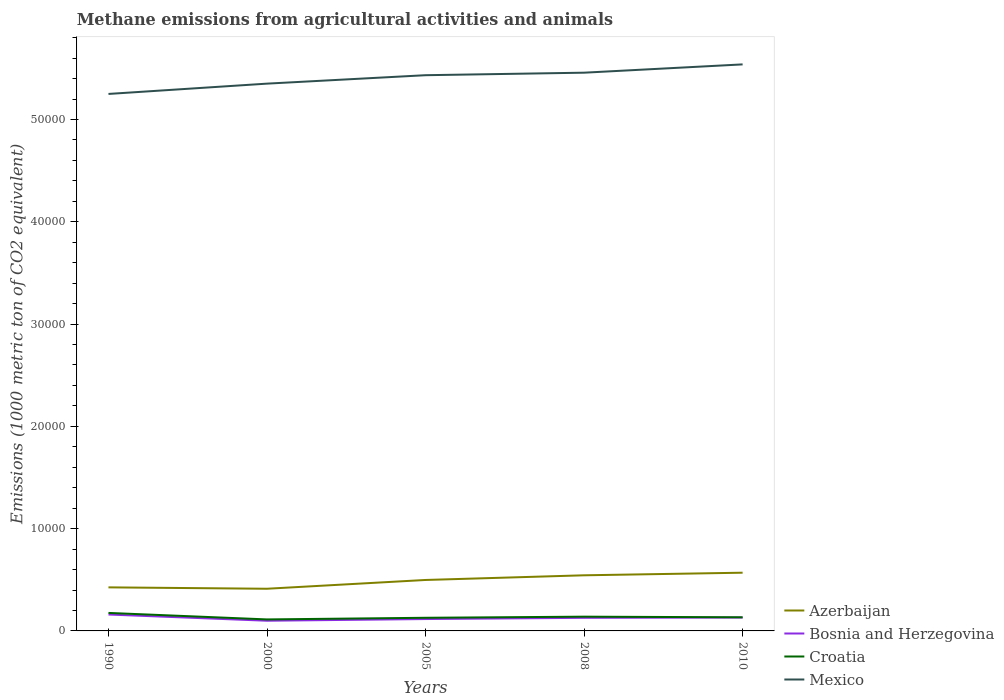Is the number of lines equal to the number of legend labels?
Offer a terse response. Yes. Across all years, what is the maximum amount of methane emitted in Azerbaijan?
Offer a terse response. 4123.5. In which year was the amount of methane emitted in Mexico maximum?
Give a very brief answer. 1990. What is the total amount of methane emitted in Mexico in the graph?
Make the answer very short. -810.5. What is the difference between the highest and the second highest amount of methane emitted in Bosnia and Herzegovina?
Your answer should be compact. 607.7. What is the difference between the highest and the lowest amount of methane emitted in Bosnia and Herzegovina?
Your answer should be very brief. 3. What is the difference between two consecutive major ticks on the Y-axis?
Offer a terse response. 10000. Are the values on the major ticks of Y-axis written in scientific E-notation?
Ensure brevity in your answer.  No. Does the graph contain grids?
Your answer should be very brief. No. Where does the legend appear in the graph?
Ensure brevity in your answer.  Bottom right. How are the legend labels stacked?
Offer a very short reply. Vertical. What is the title of the graph?
Offer a terse response. Methane emissions from agricultural activities and animals. Does "Croatia" appear as one of the legend labels in the graph?
Provide a succinct answer. Yes. What is the label or title of the Y-axis?
Offer a terse response. Emissions (1000 metric ton of CO2 equivalent). What is the Emissions (1000 metric ton of CO2 equivalent) in Azerbaijan in 1990?
Keep it short and to the point. 4258.7. What is the Emissions (1000 metric ton of CO2 equivalent) in Bosnia and Herzegovina in 1990?
Offer a terse response. 1604.3. What is the Emissions (1000 metric ton of CO2 equivalent) in Croatia in 1990?
Keep it short and to the point. 1759.1. What is the Emissions (1000 metric ton of CO2 equivalent) in Mexico in 1990?
Your response must be concise. 5.25e+04. What is the Emissions (1000 metric ton of CO2 equivalent) in Azerbaijan in 2000?
Give a very brief answer. 4123.5. What is the Emissions (1000 metric ton of CO2 equivalent) of Bosnia and Herzegovina in 2000?
Your answer should be compact. 996.6. What is the Emissions (1000 metric ton of CO2 equivalent) of Croatia in 2000?
Offer a terse response. 1124.5. What is the Emissions (1000 metric ton of CO2 equivalent) of Mexico in 2000?
Make the answer very short. 5.35e+04. What is the Emissions (1000 metric ton of CO2 equivalent) in Azerbaijan in 2005?
Provide a short and direct response. 4981. What is the Emissions (1000 metric ton of CO2 equivalent) of Bosnia and Herzegovina in 2005?
Provide a short and direct response. 1161.2. What is the Emissions (1000 metric ton of CO2 equivalent) in Croatia in 2005?
Make the answer very short. 1285.2. What is the Emissions (1000 metric ton of CO2 equivalent) of Mexico in 2005?
Offer a terse response. 5.43e+04. What is the Emissions (1000 metric ton of CO2 equivalent) of Azerbaijan in 2008?
Give a very brief answer. 5438.1. What is the Emissions (1000 metric ton of CO2 equivalent) of Bosnia and Herzegovina in 2008?
Keep it short and to the point. 1279.4. What is the Emissions (1000 metric ton of CO2 equivalent) of Croatia in 2008?
Your answer should be compact. 1392.8. What is the Emissions (1000 metric ton of CO2 equivalent) in Mexico in 2008?
Ensure brevity in your answer.  5.46e+04. What is the Emissions (1000 metric ton of CO2 equivalent) in Azerbaijan in 2010?
Give a very brief answer. 5691.1. What is the Emissions (1000 metric ton of CO2 equivalent) of Bosnia and Herzegovina in 2010?
Your answer should be very brief. 1307.1. What is the Emissions (1000 metric ton of CO2 equivalent) of Croatia in 2010?
Your answer should be very brief. 1331.3. What is the Emissions (1000 metric ton of CO2 equivalent) of Mexico in 2010?
Offer a very short reply. 5.54e+04. Across all years, what is the maximum Emissions (1000 metric ton of CO2 equivalent) of Azerbaijan?
Keep it short and to the point. 5691.1. Across all years, what is the maximum Emissions (1000 metric ton of CO2 equivalent) of Bosnia and Herzegovina?
Your response must be concise. 1604.3. Across all years, what is the maximum Emissions (1000 metric ton of CO2 equivalent) in Croatia?
Offer a terse response. 1759.1. Across all years, what is the maximum Emissions (1000 metric ton of CO2 equivalent) of Mexico?
Your response must be concise. 5.54e+04. Across all years, what is the minimum Emissions (1000 metric ton of CO2 equivalent) in Azerbaijan?
Provide a succinct answer. 4123.5. Across all years, what is the minimum Emissions (1000 metric ton of CO2 equivalent) in Bosnia and Herzegovina?
Your answer should be compact. 996.6. Across all years, what is the minimum Emissions (1000 metric ton of CO2 equivalent) in Croatia?
Make the answer very short. 1124.5. Across all years, what is the minimum Emissions (1000 metric ton of CO2 equivalent) of Mexico?
Offer a very short reply. 5.25e+04. What is the total Emissions (1000 metric ton of CO2 equivalent) of Azerbaijan in the graph?
Provide a succinct answer. 2.45e+04. What is the total Emissions (1000 metric ton of CO2 equivalent) in Bosnia and Herzegovina in the graph?
Your answer should be very brief. 6348.6. What is the total Emissions (1000 metric ton of CO2 equivalent) in Croatia in the graph?
Keep it short and to the point. 6892.9. What is the total Emissions (1000 metric ton of CO2 equivalent) in Mexico in the graph?
Provide a succinct answer. 2.70e+05. What is the difference between the Emissions (1000 metric ton of CO2 equivalent) of Azerbaijan in 1990 and that in 2000?
Your response must be concise. 135.2. What is the difference between the Emissions (1000 metric ton of CO2 equivalent) in Bosnia and Herzegovina in 1990 and that in 2000?
Your answer should be compact. 607.7. What is the difference between the Emissions (1000 metric ton of CO2 equivalent) of Croatia in 1990 and that in 2000?
Give a very brief answer. 634.6. What is the difference between the Emissions (1000 metric ton of CO2 equivalent) of Mexico in 1990 and that in 2000?
Provide a succinct answer. -1007.1. What is the difference between the Emissions (1000 metric ton of CO2 equivalent) of Azerbaijan in 1990 and that in 2005?
Provide a succinct answer. -722.3. What is the difference between the Emissions (1000 metric ton of CO2 equivalent) in Bosnia and Herzegovina in 1990 and that in 2005?
Your answer should be very brief. 443.1. What is the difference between the Emissions (1000 metric ton of CO2 equivalent) of Croatia in 1990 and that in 2005?
Keep it short and to the point. 473.9. What is the difference between the Emissions (1000 metric ton of CO2 equivalent) in Mexico in 1990 and that in 2005?
Keep it short and to the point. -1831.1. What is the difference between the Emissions (1000 metric ton of CO2 equivalent) of Azerbaijan in 1990 and that in 2008?
Your answer should be very brief. -1179.4. What is the difference between the Emissions (1000 metric ton of CO2 equivalent) of Bosnia and Herzegovina in 1990 and that in 2008?
Keep it short and to the point. 324.9. What is the difference between the Emissions (1000 metric ton of CO2 equivalent) of Croatia in 1990 and that in 2008?
Offer a very short reply. 366.3. What is the difference between the Emissions (1000 metric ton of CO2 equivalent) in Mexico in 1990 and that in 2008?
Provide a short and direct response. -2077.8. What is the difference between the Emissions (1000 metric ton of CO2 equivalent) of Azerbaijan in 1990 and that in 2010?
Provide a short and direct response. -1432.4. What is the difference between the Emissions (1000 metric ton of CO2 equivalent) of Bosnia and Herzegovina in 1990 and that in 2010?
Provide a succinct answer. 297.2. What is the difference between the Emissions (1000 metric ton of CO2 equivalent) of Croatia in 1990 and that in 2010?
Provide a short and direct response. 427.8. What is the difference between the Emissions (1000 metric ton of CO2 equivalent) in Mexico in 1990 and that in 2010?
Keep it short and to the point. -2888.3. What is the difference between the Emissions (1000 metric ton of CO2 equivalent) in Azerbaijan in 2000 and that in 2005?
Your answer should be compact. -857.5. What is the difference between the Emissions (1000 metric ton of CO2 equivalent) of Bosnia and Herzegovina in 2000 and that in 2005?
Offer a terse response. -164.6. What is the difference between the Emissions (1000 metric ton of CO2 equivalent) of Croatia in 2000 and that in 2005?
Provide a succinct answer. -160.7. What is the difference between the Emissions (1000 metric ton of CO2 equivalent) in Mexico in 2000 and that in 2005?
Offer a terse response. -824. What is the difference between the Emissions (1000 metric ton of CO2 equivalent) in Azerbaijan in 2000 and that in 2008?
Offer a very short reply. -1314.6. What is the difference between the Emissions (1000 metric ton of CO2 equivalent) in Bosnia and Herzegovina in 2000 and that in 2008?
Make the answer very short. -282.8. What is the difference between the Emissions (1000 metric ton of CO2 equivalent) of Croatia in 2000 and that in 2008?
Your response must be concise. -268.3. What is the difference between the Emissions (1000 metric ton of CO2 equivalent) of Mexico in 2000 and that in 2008?
Provide a succinct answer. -1070.7. What is the difference between the Emissions (1000 metric ton of CO2 equivalent) of Azerbaijan in 2000 and that in 2010?
Give a very brief answer. -1567.6. What is the difference between the Emissions (1000 metric ton of CO2 equivalent) in Bosnia and Herzegovina in 2000 and that in 2010?
Keep it short and to the point. -310.5. What is the difference between the Emissions (1000 metric ton of CO2 equivalent) of Croatia in 2000 and that in 2010?
Make the answer very short. -206.8. What is the difference between the Emissions (1000 metric ton of CO2 equivalent) in Mexico in 2000 and that in 2010?
Give a very brief answer. -1881.2. What is the difference between the Emissions (1000 metric ton of CO2 equivalent) of Azerbaijan in 2005 and that in 2008?
Give a very brief answer. -457.1. What is the difference between the Emissions (1000 metric ton of CO2 equivalent) in Bosnia and Herzegovina in 2005 and that in 2008?
Your response must be concise. -118.2. What is the difference between the Emissions (1000 metric ton of CO2 equivalent) of Croatia in 2005 and that in 2008?
Provide a succinct answer. -107.6. What is the difference between the Emissions (1000 metric ton of CO2 equivalent) of Mexico in 2005 and that in 2008?
Your answer should be compact. -246.7. What is the difference between the Emissions (1000 metric ton of CO2 equivalent) of Azerbaijan in 2005 and that in 2010?
Provide a short and direct response. -710.1. What is the difference between the Emissions (1000 metric ton of CO2 equivalent) of Bosnia and Herzegovina in 2005 and that in 2010?
Your response must be concise. -145.9. What is the difference between the Emissions (1000 metric ton of CO2 equivalent) of Croatia in 2005 and that in 2010?
Keep it short and to the point. -46.1. What is the difference between the Emissions (1000 metric ton of CO2 equivalent) of Mexico in 2005 and that in 2010?
Give a very brief answer. -1057.2. What is the difference between the Emissions (1000 metric ton of CO2 equivalent) of Azerbaijan in 2008 and that in 2010?
Make the answer very short. -253. What is the difference between the Emissions (1000 metric ton of CO2 equivalent) in Bosnia and Herzegovina in 2008 and that in 2010?
Provide a short and direct response. -27.7. What is the difference between the Emissions (1000 metric ton of CO2 equivalent) in Croatia in 2008 and that in 2010?
Give a very brief answer. 61.5. What is the difference between the Emissions (1000 metric ton of CO2 equivalent) of Mexico in 2008 and that in 2010?
Your response must be concise. -810.5. What is the difference between the Emissions (1000 metric ton of CO2 equivalent) in Azerbaijan in 1990 and the Emissions (1000 metric ton of CO2 equivalent) in Bosnia and Herzegovina in 2000?
Ensure brevity in your answer.  3262.1. What is the difference between the Emissions (1000 metric ton of CO2 equivalent) in Azerbaijan in 1990 and the Emissions (1000 metric ton of CO2 equivalent) in Croatia in 2000?
Provide a short and direct response. 3134.2. What is the difference between the Emissions (1000 metric ton of CO2 equivalent) in Azerbaijan in 1990 and the Emissions (1000 metric ton of CO2 equivalent) in Mexico in 2000?
Offer a terse response. -4.92e+04. What is the difference between the Emissions (1000 metric ton of CO2 equivalent) of Bosnia and Herzegovina in 1990 and the Emissions (1000 metric ton of CO2 equivalent) of Croatia in 2000?
Your response must be concise. 479.8. What is the difference between the Emissions (1000 metric ton of CO2 equivalent) of Bosnia and Herzegovina in 1990 and the Emissions (1000 metric ton of CO2 equivalent) of Mexico in 2000?
Keep it short and to the point. -5.19e+04. What is the difference between the Emissions (1000 metric ton of CO2 equivalent) of Croatia in 1990 and the Emissions (1000 metric ton of CO2 equivalent) of Mexico in 2000?
Provide a succinct answer. -5.17e+04. What is the difference between the Emissions (1000 metric ton of CO2 equivalent) of Azerbaijan in 1990 and the Emissions (1000 metric ton of CO2 equivalent) of Bosnia and Herzegovina in 2005?
Ensure brevity in your answer.  3097.5. What is the difference between the Emissions (1000 metric ton of CO2 equivalent) in Azerbaijan in 1990 and the Emissions (1000 metric ton of CO2 equivalent) in Croatia in 2005?
Keep it short and to the point. 2973.5. What is the difference between the Emissions (1000 metric ton of CO2 equivalent) in Azerbaijan in 1990 and the Emissions (1000 metric ton of CO2 equivalent) in Mexico in 2005?
Provide a short and direct response. -5.01e+04. What is the difference between the Emissions (1000 metric ton of CO2 equivalent) of Bosnia and Herzegovina in 1990 and the Emissions (1000 metric ton of CO2 equivalent) of Croatia in 2005?
Give a very brief answer. 319.1. What is the difference between the Emissions (1000 metric ton of CO2 equivalent) of Bosnia and Herzegovina in 1990 and the Emissions (1000 metric ton of CO2 equivalent) of Mexico in 2005?
Your response must be concise. -5.27e+04. What is the difference between the Emissions (1000 metric ton of CO2 equivalent) in Croatia in 1990 and the Emissions (1000 metric ton of CO2 equivalent) in Mexico in 2005?
Offer a very short reply. -5.26e+04. What is the difference between the Emissions (1000 metric ton of CO2 equivalent) in Azerbaijan in 1990 and the Emissions (1000 metric ton of CO2 equivalent) in Bosnia and Herzegovina in 2008?
Offer a terse response. 2979.3. What is the difference between the Emissions (1000 metric ton of CO2 equivalent) of Azerbaijan in 1990 and the Emissions (1000 metric ton of CO2 equivalent) of Croatia in 2008?
Your response must be concise. 2865.9. What is the difference between the Emissions (1000 metric ton of CO2 equivalent) in Azerbaijan in 1990 and the Emissions (1000 metric ton of CO2 equivalent) in Mexico in 2008?
Your answer should be very brief. -5.03e+04. What is the difference between the Emissions (1000 metric ton of CO2 equivalent) of Bosnia and Herzegovina in 1990 and the Emissions (1000 metric ton of CO2 equivalent) of Croatia in 2008?
Keep it short and to the point. 211.5. What is the difference between the Emissions (1000 metric ton of CO2 equivalent) of Bosnia and Herzegovina in 1990 and the Emissions (1000 metric ton of CO2 equivalent) of Mexico in 2008?
Offer a terse response. -5.30e+04. What is the difference between the Emissions (1000 metric ton of CO2 equivalent) of Croatia in 1990 and the Emissions (1000 metric ton of CO2 equivalent) of Mexico in 2008?
Your answer should be compact. -5.28e+04. What is the difference between the Emissions (1000 metric ton of CO2 equivalent) in Azerbaijan in 1990 and the Emissions (1000 metric ton of CO2 equivalent) in Bosnia and Herzegovina in 2010?
Your answer should be compact. 2951.6. What is the difference between the Emissions (1000 metric ton of CO2 equivalent) in Azerbaijan in 1990 and the Emissions (1000 metric ton of CO2 equivalent) in Croatia in 2010?
Make the answer very short. 2927.4. What is the difference between the Emissions (1000 metric ton of CO2 equivalent) in Azerbaijan in 1990 and the Emissions (1000 metric ton of CO2 equivalent) in Mexico in 2010?
Your answer should be compact. -5.11e+04. What is the difference between the Emissions (1000 metric ton of CO2 equivalent) of Bosnia and Herzegovina in 1990 and the Emissions (1000 metric ton of CO2 equivalent) of Croatia in 2010?
Your response must be concise. 273. What is the difference between the Emissions (1000 metric ton of CO2 equivalent) of Bosnia and Herzegovina in 1990 and the Emissions (1000 metric ton of CO2 equivalent) of Mexico in 2010?
Offer a very short reply. -5.38e+04. What is the difference between the Emissions (1000 metric ton of CO2 equivalent) in Croatia in 1990 and the Emissions (1000 metric ton of CO2 equivalent) in Mexico in 2010?
Provide a succinct answer. -5.36e+04. What is the difference between the Emissions (1000 metric ton of CO2 equivalent) of Azerbaijan in 2000 and the Emissions (1000 metric ton of CO2 equivalent) of Bosnia and Herzegovina in 2005?
Keep it short and to the point. 2962.3. What is the difference between the Emissions (1000 metric ton of CO2 equivalent) of Azerbaijan in 2000 and the Emissions (1000 metric ton of CO2 equivalent) of Croatia in 2005?
Make the answer very short. 2838.3. What is the difference between the Emissions (1000 metric ton of CO2 equivalent) of Azerbaijan in 2000 and the Emissions (1000 metric ton of CO2 equivalent) of Mexico in 2005?
Offer a very short reply. -5.02e+04. What is the difference between the Emissions (1000 metric ton of CO2 equivalent) of Bosnia and Herzegovina in 2000 and the Emissions (1000 metric ton of CO2 equivalent) of Croatia in 2005?
Provide a short and direct response. -288.6. What is the difference between the Emissions (1000 metric ton of CO2 equivalent) in Bosnia and Herzegovina in 2000 and the Emissions (1000 metric ton of CO2 equivalent) in Mexico in 2005?
Provide a short and direct response. -5.33e+04. What is the difference between the Emissions (1000 metric ton of CO2 equivalent) of Croatia in 2000 and the Emissions (1000 metric ton of CO2 equivalent) of Mexico in 2005?
Ensure brevity in your answer.  -5.32e+04. What is the difference between the Emissions (1000 metric ton of CO2 equivalent) in Azerbaijan in 2000 and the Emissions (1000 metric ton of CO2 equivalent) in Bosnia and Herzegovina in 2008?
Make the answer very short. 2844.1. What is the difference between the Emissions (1000 metric ton of CO2 equivalent) in Azerbaijan in 2000 and the Emissions (1000 metric ton of CO2 equivalent) in Croatia in 2008?
Provide a short and direct response. 2730.7. What is the difference between the Emissions (1000 metric ton of CO2 equivalent) of Azerbaijan in 2000 and the Emissions (1000 metric ton of CO2 equivalent) of Mexico in 2008?
Give a very brief answer. -5.05e+04. What is the difference between the Emissions (1000 metric ton of CO2 equivalent) in Bosnia and Herzegovina in 2000 and the Emissions (1000 metric ton of CO2 equivalent) in Croatia in 2008?
Provide a short and direct response. -396.2. What is the difference between the Emissions (1000 metric ton of CO2 equivalent) of Bosnia and Herzegovina in 2000 and the Emissions (1000 metric ton of CO2 equivalent) of Mexico in 2008?
Your answer should be compact. -5.36e+04. What is the difference between the Emissions (1000 metric ton of CO2 equivalent) in Croatia in 2000 and the Emissions (1000 metric ton of CO2 equivalent) in Mexico in 2008?
Provide a succinct answer. -5.35e+04. What is the difference between the Emissions (1000 metric ton of CO2 equivalent) in Azerbaijan in 2000 and the Emissions (1000 metric ton of CO2 equivalent) in Bosnia and Herzegovina in 2010?
Keep it short and to the point. 2816.4. What is the difference between the Emissions (1000 metric ton of CO2 equivalent) in Azerbaijan in 2000 and the Emissions (1000 metric ton of CO2 equivalent) in Croatia in 2010?
Provide a succinct answer. 2792.2. What is the difference between the Emissions (1000 metric ton of CO2 equivalent) of Azerbaijan in 2000 and the Emissions (1000 metric ton of CO2 equivalent) of Mexico in 2010?
Provide a short and direct response. -5.13e+04. What is the difference between the Emissions (1000 metric ton of CO2 equivalent) in Bosnia and Herzegovina in 2000 and the Emissions (1000 metric ton of CO2 equivalent) in Croatia in 2010?
Your answer should be compact. -334.7. What is the difference between the Emissions (1000 metric ton of CO2 equivalent) in Bosnia and Herzegovina in 2000 and the Emissions (1000 metric ton of CO2 equivalent) in Mexico in 2010?
Offer a very short reply. -5.44e+04. What is the difference between the Emissions (1000 metric ton of CO2 equivalent) of Croatia in 2000 and the Emissions (1000 metric ton of CO2 equivalent) of Mexico in 2010?
Keep it short and to the point. -5.43e+04. What is the difference between the Emissions (1000 metric ton of CO2 equivalent) in Azerbaijan in 2005 and the Emissions (1000 metric ton of CO2 equivalent) in Bosnia and Herzegovina in 2008?
Provide a succinct answer. 3701.6. What is the difference between the Emissions (1000 metric ton of CO2 equivalent) in Azerbaijan in 2005 and the Emissions (1000 metric ton of CO2 equivalent) in Croatia in 2008?
Keep it short and to the point. 3588.2. What is the difference between the Emissions (1000 metric ton of CO2 equivalent) of Azerbaijan in 2005 and the Emissions (1000 metric ton of CO2 equivalent) of Mexico in 2008?
Keep it short and to the point. -4.96e+04. What is the difference between the Emissions (1000 metric ton of CO2 equivalent) of Bosnia and Herzegovina in 2005 and the Emissions (1000 metric ton of CO2 equivalent) of Croatia in 2008?
Ensure brevity in your answer.  -231.6. What is the difference between the Emissions (1000 metric ton of CO2 equivalent) in Bosnia and Herzegovina in 2005 and the Emissions (1000 metric ton of CO2 equivalent) in Mexico in 2008?
Offer a very short reply. -5.34e+04. What is the difference between the Emissions (1000 metric ton of CO2 equivalent) in Croatia in 2005 and the Emissions (1000 metric ton of CO2 equivalent) in Mexico in 2008?
Provide a short and direct response. -5.33e+04. What is the difference between the Emissions (1000 metric ton of CO2 equivalent) of Azerbaijan in 2005 and the Emissions (1000 metric ton of CO2 equivalent) of Bosnia and Herzegovina in 2010?
Your response must be concise. 3673.9. What is the difference between the Emissions (1000 metric ton of CO2 equivalent) of Azerbaijan in 2005 and the Emissions (1000 metric ton of CO2 equivalent) of Croatia in 2010?
Your response must be concise. 3649.7. What is the difference between the Emissions (1000 metric ton of CO2 equivalent) of Azerbaijan in 2005 and the Emissions (1000 metric ton of CO2 equivalent) of Mexico in 2010?
Provide a succinct answer. -5.04e+04. What is the difference between the Emissions (1000 metric ton of CO2 equivalent) of Bosnia and Herzegovina in 2005 and the Emissions (1000 metric ton of CO2 equivalent) of Croatia in 2010?
Offer a terse response. -170.1. What is the difference between the Emissions (1000 metric ton of CO2 equivalent) of Bosnia and Herzegovina in 2005 and the Emissions (1000 metric ton of CO2 equivalent) of Mexico in 2010?
Your answer should be compact. -5.42e+04. What is the difference between the Emissions (1000 metric ton of CO2 equivalent) of Croatia in 2005 and the Emissions (1000 metric ton of CO2 equivalent) of Mexico in 2010?
Ensure brevity in your answer.  -5.41e+04. What is the difference between the Emissions (1000 metric ton of CO2 equivalent) of Azerbaijan in 2008 and the Emissions (1000 metric ton of CO2 equivalent) of Bosnia and Herzegovina in 2010?
Ensure brevity in your answer.  4131. What is the difference between the Emissions (1000 metric ton of CO2 equivalent) of Azerbaijan in 2008 and the Emissions (1000 metric ton of CO2 equivalent) of Croatia in 2010?
Provide a succinct answer. 4106.8. What is the difference between the Emissions (1000 metric ton of CO2 equivalent) of Azerbaijan in 2008 and the Emissions (1000 metric ton of CO2 equivalent) of Mexico in 2010?
Your answer should be very brief. -4.99e+04. What is the difference between the Emissions (1000 metric ton of CO2 equivalent) in Bosnia and Herzegovina in 2008 and the Emissions (1000 metric ton of CO2 equivalent) in Croatia in 2010?
Your answer should be compact. -51.9. What is the difference between the Emissions (1000 metric ton of CO2 equivalent) in Bosnia and Herzegovina in 2008 and the Emissions (1000 metric ton of CO2 equivalent) in Mexico in 2010?
Provide a succinct answer. -5.41e+04. What is the difference between the Emissions (1000 metric ton of CO2 equivalent) of Croatia in 2008 and the Emissions (1000 metric ton of CO2 equivalent) of Mexico in 2010?
Your answer should be compact. -5.40e+04. What is the average Emissions (1000 metric ton of CO2 equivalent) of Azerbaijan per year?
Offer a terse response. 4898.48. What is the average Emissions (1000 metric ton of CO2 equivalent) of Bosnia and Herzegovina per year?
Ensure brevity in your answer.  1269.72. What is the average Emissions (1000 metric ton of CO2 equivalent) of Croatia per year?
Ensure brevity in your answer.  1378.58. What is the average Emissions (1000 metric ton of CO2 equivalent) of Mexico per year?
Your answer should be compact. 5.41e+04. In the year 1990, what is the difference between the Emissions (1000 metric ton of CO2 equivalent) in Azerbaijan and Emissions (1000 metric ton of CO2 equivalent) in Bosnia and Herzegovina?
Your response must be concise. 2654.4. In the year 1990, what is the difference between the Emissions (1000 metric ton of CO2 equivalent) of Azerbaijan and Emissions (1000 metric ton of CO2 equivalent) of Croatia?
Your response must be concise. 2499.6. In the year 1990, what is the difference between the Emissions (1000 metric ton of CO2 equivalent) of Azerbaijan and Emissions (1000 metric ton of CO2 equivalent) of Mexico?
Your answer should be very brief. -4.82e+04. In the year 1990, what is the difference between the Emissions (1000 metric ton of CO2 equivalent) of Bosnia and Herzegovina and Emissions (1000 metric ton of CO2 equivalent) of Croatia?
Give a very brief answer. -154.8. In the year 1990, what is the difference between the Emissions (1000 metric ton of CO2 equivalent) in Bosnia and Herzegovina and Emissions (1000 metric ton of CO2 equivalent) in Mexico?
Offer a terse response. -5.09e+04. In the year 1990, what is the difference between the Emissions (1000 metric ton of CO2 equivalent) of Croatia and Emissions (1000 metric ton of CO2 equivalent) of Mexico?
Give a very brief answer. -5.07e+04. In the year 2000, what is the difference between the Emissions (1000 metric ton of CO2 equivalent) of Azerbaijan and Emissions (1000 metric ton of CO2 equivalent) of Bosnia and Herzegovina?
Your answer should be compact. 3126.9. In the year 2000, what is the difference between the Emissions (1000 metric ton of CO2 equivalent) in Azerbaijan and Emissions (1000 metric ton of CO2 equivalent) in Croatia?
Your answer should be compact. 2999. In the year 2000, what is the difference between the Emissions (1000 metric ton of CO2 equivalent) of Azerbaijan and Emissions (1000 metric ton of CO2 equivalent) of Mexico?
Your response must be concise. -4.94e+04. In the year 2000, what is the difference between the Emissions (1000 metric ton of CO2 equivalent) of Bosnia and Herzegovina and Emissions (1000 metric ton of CO2 equivalent) of Croatia?
Offer a terse response. -127.9. In the year 2000, what is the difference between the Emissions (1000 metric ton of CO2 equivalent) in Bosnia and Herzegovina and Emissions (1000 metric ton of CO2 equivalent) in Mexico?
Give a very brief answer. -5.25e+04. In the year 2000, what is the difference between the Emissions (1000 metric ton of CO2 equivalent) of Croatia and Emissions (1000 metric ton of CO2 equivalent) of Mexico?
Offer a very short reply. -5.24e+04. In the year 2005, what is the difference between the Emissions (1000 metric ton of CO2 equivalent) of Azerbaijan and Emissions (1000 metric ton of CO2 equivalent) of Bosnia and Herzegovina?
Offer a very short reply. 3819.8. In the year 2005, what is the difference between the Emissions (1000 metric ton of CO2 equivalent) of Azerbaijan and Emissions (1000 metric ton of CO2 equivalent) of Croatia?
Provide a succinct answer. 3695.8. In the year 2005, what is the difference between the Emissions (1000 metric ton of CO2 equivalent) of Azerbaijan and Emissions (1000 metric ton of CO2 equivalent) of Mexico?
Ensure brevity in your answer.  -4.93e+04. In the year 2005, what is the difference between the Emissions (1000 metric ton of CO2 equivalent) of Bosnia and Herzegovina and Emissions (1000 metric ton of CO2 equivalent) of Croatia?
Keep it short and to the point. -124. In the year 2005, what is the difference between the Emissions (1000 metric ton of CO2 equivalent) of Bosnia and Herzegovina and Emissions (1000 metric ton of CO2 equivalent) of Mexico?
Provide a short and direct response. -5.32e+04. In the year 2005, what is the difference between the Emissions (1000 metric ton of CO2 equivalent) in Croatia and Emissions (1000 metric ton of CO2 equivalent) in Mexico?
Your answer should be very brief. -5.30e+04. In the year 2008, what is the difference between the Emissions (1000 metric ton of CO2 equivalent) in Azerbaijan and Emissions (1000 metric ton of CO2 equivalent) in Bosnia and Herzegovina?
Your answer should be very brief. 4158.7. In the year 2008, what is the difference between the Emissions (1000 metric ton of CO2 equivalent) in Azerbaijan and Emissions (1000 metric ton of CO2 equivalent) in Croatia?
Ensure brevity in your answer.  4045.3. In the year 2008, what is the difference between the Emissions (1000 metric ton of CO2 equivalent) in Azerbaijan and Emissions (1000 metric ton of CO2 equivalent) in Mexico?
Make the answer very short. -4.91e+04. In the year 2008, what is the difference between the Emissions (1000 metric ton of CO2 equivalent) of Bosnia and Herzegovina and Emissions (1000 metric ton of CO2 equivalent) of Croatia?
Your response must be concise. -113.4. In the year 2008, what is the difference between the Emissions (1000 metric ton of CO2 equivalent) of Bosnia and Herzegovina and Emissions (1000 metric ton of CO2 equivalent) of Mexico?
Make the answer very short. -5.33e+04. In the year 2008, what is the difference between the Emissions (1000 metric ton of CO2 equivalent) of Croatia and Emissions (1000 metric ton of CO2 equivalent) of Mexico?
Your answer should be very brief. -5.32e+04. In the year 2010, what is the difference between the Emissions (1000 metric ton of CO2 equivalent) of Azerbaijan and Emissions (1000 metric ton of CO2 equivalent) of Bosnia and Herzegovina?
Your answer should be compact. 4384. In the year 2010, what is the difference between the Emissions (1000 metric ton of CO2 equivalent) in Azerbaijan and Emissions (1000 metric ton of CO2 equivalent) in Croatia?
Provide a short and direct response. 4359.8. In the year 2010, what is the difference between the Emissions (1000 metric ton of CO2 equivalent) in Azerbaijan and Emissions (1000 metric ton of CO2 equivalent) in Mexico?
Your answer should be very brief. -4.97e+04. In the year 2010, what is the difference between the Emissions (1000 metric ton of CO2 equivalent) in Bosnia and Herzegovina and Emissions (1000 metric ton of CO2 equivalent) in Croatia?
Your answer should be very brief. -24.2. In the year 2010, what is the difference between the Emissions (1000 metric ton of CO2 equivalent) in Bosnia and Herzegovina and Emissions (1000 metric ton of CO2 equivalent) in Mexico?
Your response must be concise. -5.41e+04. In the year 2010, what is the difference between the Emissions (1000 metric ton of CO2 equivalent) in Croatia and Emissions (1000 metric ton of CO2 equivalent) in Mexico?
Keep it short and to the point. -5.41e+04. What is the ratio of the Emissions (1000 metric ton of CO2 equivalent) of Azerbaijan in 1990 to that in 2000?
Your response must be concise. 1.03. What is the ratio of the Emissions (1000 metric ton of CO2 equivalent) of Bosnia and Herzegovina in 1990 to that in 2000?
Give a very brief answer. 1.61. What is the ratio of the Emissions (1000 metric ton of CO2 equivalent) in Croatia in 1990 to that in 2000?
Ensure brevity in your answer.  1.56. What is the ratio of the Emissions (1000 metric ton of CO2 equivalent) of Mexico in 1990 to that in 2000?
Provide a succinct answer. 0.98. What is the ratio of the Emissions (1000 metric ton of CO2 equivalent) in Azerbaijan in 1990 to that in 2005?
Provide a short and direct response. 0.85. What is the ratio of the Emissions (1000 metric ton of CO2 equivalent) of Bosnia and Herzegovina in 1990 to that in 2005?
Your answer should be compact. 1.38. What is the ratio of the Emissions (1000 metric ton of CO2 equivalent) of Croatia in 1990 to that in 2005?
Make the answer very short. 1.37. What is the ratio of the Emissions (1000 metric ton of CO2 equivalent) of Mexico in 1990 to that in 2005?
Give a very brief answer. 0.97. What is the ratio of the Emissions (1000 metric ton of CO2 equivalent) of Azerbaijan in 1990 to that in 2008?
Keep it short and to the point. 0.78. What is the ratio of the Emissions (1000 metric ton of CO2 equivalent) in Bosnia and Herzegovina in 1990 to that in 2008?
Offer a very short reply. 1.25. What is the ratio of the Emissions (1000 metric ton of CO2 equivalent) in Croatia in 1990 to that in 2008?
Make the answer very short. 1.26. What is the ratio of the Emissions (1000 metric ton of CO2 equivalent) in Mexico in 1990 to that in 2008?
Offer a terse response. 0.96. What is the ratio of the Emissions (1000 metric ton of CO2 equivalent) of Azerbaijan in 1990 to that in 2010?
Your response must be concise. 0.75. What is the ratio of the Emissions (1000 metric ton of CO2 equivalent) in Bosnia and Herzegovina in 1990 to that in 2010?
Ensure brevity in your answer.  1.23. What is the ratio of the Emissions (1000 metric ton of CO2 equivalent) in Croatia in 1990 to that in 2010?
Offer a very short reply. 1.32. What is the ratio of the Emissions (1000 metric ton of CO2 equivalent) in Mexico in 1990 to that in 2010?
Provide a short and direct response. 0.95. What is the ratio of the Emissions (1000 metric ton of CO2 equivalent) of Azerbaijan in 2000 to that in 2005?
Make the answer very short. 0.83. What is the ratio of the Emissions (1000 metric ton of CO2 equivalent) in Bosnia and Herzegovina in 2000 to that in 2005?
Offer a terse response. 0.86. What is the ratio of the Emissions (1000 metric ton of CO2 equivalent) in Croatia in 2000 to that in 2005?
Ensure brevity in your answer.  0.88. What is the ratio of the Emissions (1000 metric ton of CO2 equivalent) of Mexico in 2000 to that in 2005?
Offer a very short reply. 0.98. What is the ratio of the Emissions (1000 metric ton of CO2 equivalent) in Azerbaijan in 2000 to that in 2008?
Keep it short and to the point. 0.76. What is the ratio of the Emissions (1000 metric ton of CO2 equivalent) of Bosnia and Herzegovina in 2000 to that in 2008?
Your response must be concise. 0.78. What is the ratio of the Emissions (1000 metric ton of CO2 equivalent) of Croatia in 2000 to that in 2008?
Provide a short and direct response. 0.81. What is the ratio of the Emissions (1000 metric ton of CO2 equivalent) of Mexico in 2000 to that in 2008?
Your response must be concise. 0.98. What is the ratio of the Emissions (1000 metric ton of CO2 equivalent) in Azerbaijan in 2000 to that in 2010?
Offer a terse response. 0.72. What is the ratio of the Emissions (1000 metric ton of CO2 equivalent) of Bosnia and Herzegovina in 2000 to that in 2010?
Keep it short and to the point. 0.76. What is the ratio of the Emissions (1000 metric ton of CO2 equivalent) in Croatia in 2000 to that in 2010?
Provide a succinct answer. 0.84. What is the ratio of the Emissions (1000 metric ton of CO2 equivalent) of Mexico in 2000 to that in 2010?
Your answer should be very brief. 0.97. What is the ratio of the Emissions (1000 metric ton of CO2 equivalent) in Azerbaijan in 2005 to that in 2008?
Provide a short and direct response. 0.92. What is the ratio of the Emissions (1000 metric ton of CO2 equivalent) in Bosnia and Herzegovina in 2005 to that in 2008?
Provide a short and direct response. 0.91. What is the ratio of the Emissions (1000 metric ton of CO2 equivalent) of Croatia in 2005 to that in 2008?
Your answer should be very brief. 0.92. What is the ratio of the Emissions (1000 metric ton of CO2 equivalent) in Mexico in 2005 to that in 2008?
Your answer should be compact. 1. What is the ratio of the Emissions (1000 metric ton of CO2 equivalent) of Azerbaijan in 2005 to that in 2010?
Your response must be concise. 0.88. What is the ratio of the Emissions (1000 metric ton of CO2 equivalent) of Bosnia and Herzegovina in 2005 to that in 2010?
Ensure brevity in your answer.  0.89. What is the ratio of the Emissions (1000 metric ton of CO2 equivalent) in Croatia in 2005 to that in 2010?
Keep it short and to the point. 0.97. What is the ratio of the Emissions (1000 metric ton of CO2 equivalent) in Mexico in 2005 to that in 2010?
Ensure brevity in your answer.  0.98. What is the ratio of the Emissions (1000 metric ton of CO2 equivalent) in Azerbaijan in 2008 to that in 2010?
Your answer should be compact. 0.96. What is the ratio of the Emissions (1000 metric ton of CO2 equivalent) of Bosnia and Herzegovina in 2008 to that in 2010?
Keep it short and to the point. 0.98. What is the ratio of the Emissions (1000 metric ton of CO2 equivalent) of Croatia in 2008 to that in 2010?
Offer a very short reply. 1.05. What is the ratio of the Emissions (1000 metric ton of CO2 equivalent) in Mexico in 2008 to that in 2010?
Your answer should be very brief. 0.99. What is the difference between the highest and the second highest Emissions (1000 metric ton of CO2 equivalent) of Azerbaijan?
Provide a short and direct response. 253. What is the difference between the highest and the second highest Emissions (1000 metric ton of CO2 equivalent) in Bosnia and Herzegovina?
Offer a terse response. 297.2. What is the difference between the highest and the second highest Emissions (1000 metric ton of CO2 equivalent) of Croatia?
Provide a succinct answer. 366.3. What is the difference between the highest and the second highest Emissions (1000 metric ton of CO2 equivalent) of Mexico?
Offer a terse response. 810.5. What is the difference between the highest and the lowest Emissions (1000 metric ton of CO2 equivalent) in Azerbaijan?
Provide a short and direct response. 1567.6. What is the difference between the highest and the lowest Emissions (1000 metric ton of CO2 equivalent) of Bosnia and Herzegovina?
Your answer should be very brief. 607.7. What is the difference between the highest and the lowest Emissions (1000 metric ton of CO2 equivalent) in Croatia?
Provide a short and direct response. 634.6. What is the difference between the highest and the lowest Emissions (1000 metric ton of CO2 equivalent) in Mexico?
Your answer should be compact. 2888.3. 